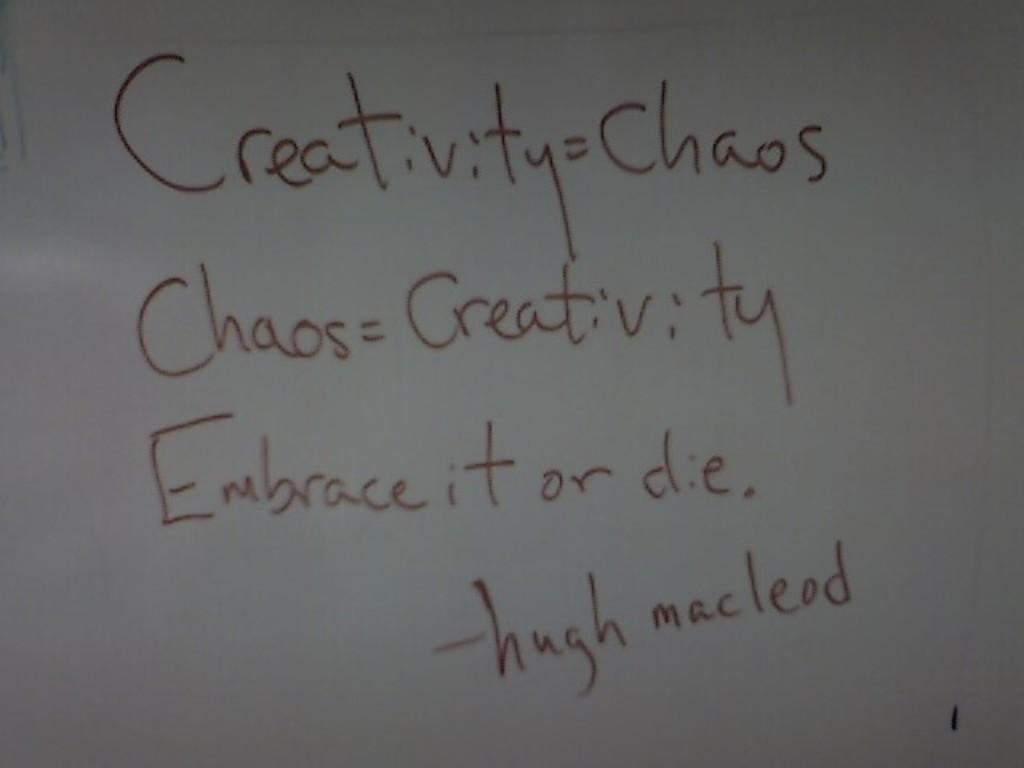<image>
Describe the image concisely. Someone has written that creativity and chaos are the same thing. 